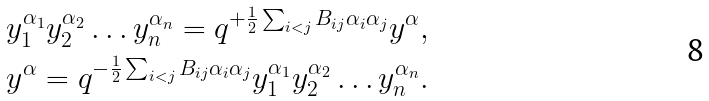Convert formula to latex. <formula><loc_0><loc_0><loc_500><loc_500>& y _ { 1 } ^ { \alpha _ { 1 } } y _ { 2 } ^ { \alpha _ { 2 } } \dots y _ { n } ^ { \alpha _ { n } } = q ^ { + \frac { 1 } { 2 } \sum _ { i < j } B _ { i j } \alpha _ { i } \alpha _ { j } } y ^ { \alpha } , \\ & y ^ { \alpha } = q ^ { - \frac { 1 } { 2 } \sum _ { i < j } B _ { i j } \alpha _ { i } \alpha _ { j } } y _ { 1 } ^ { \alpha _ { 1 } } y _ { 2 } ^ { \alpha _ { 2 } } \dots y _ { n } ^ { \alpha _ { n } } .</formula> 